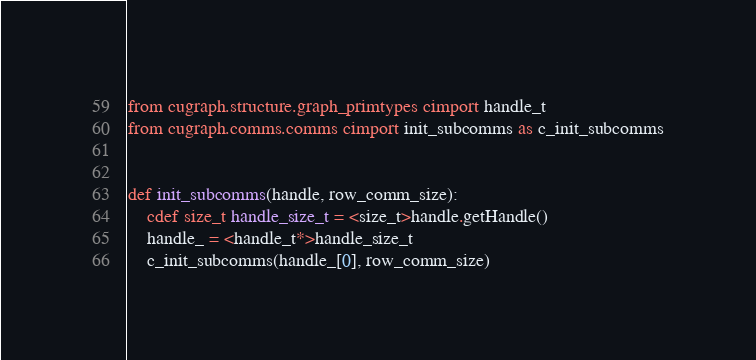<code> <loc_0><loc_0><loc_500><loc_500><_Cython_>
from cugraph.structure.graph_primtypes cimport handle_t
from cugraph.comms.comms cimport init_subcomms as c_init_subcomms


def init_subcomms(handle, row_comm_size):
    cdef size_t handle_size_t = <size_t>handle.getHandle()
    handle_ = <handle_t*>handle_size_t
    c_init_subcomms(handle_[0], row_comm_size)
</code> 